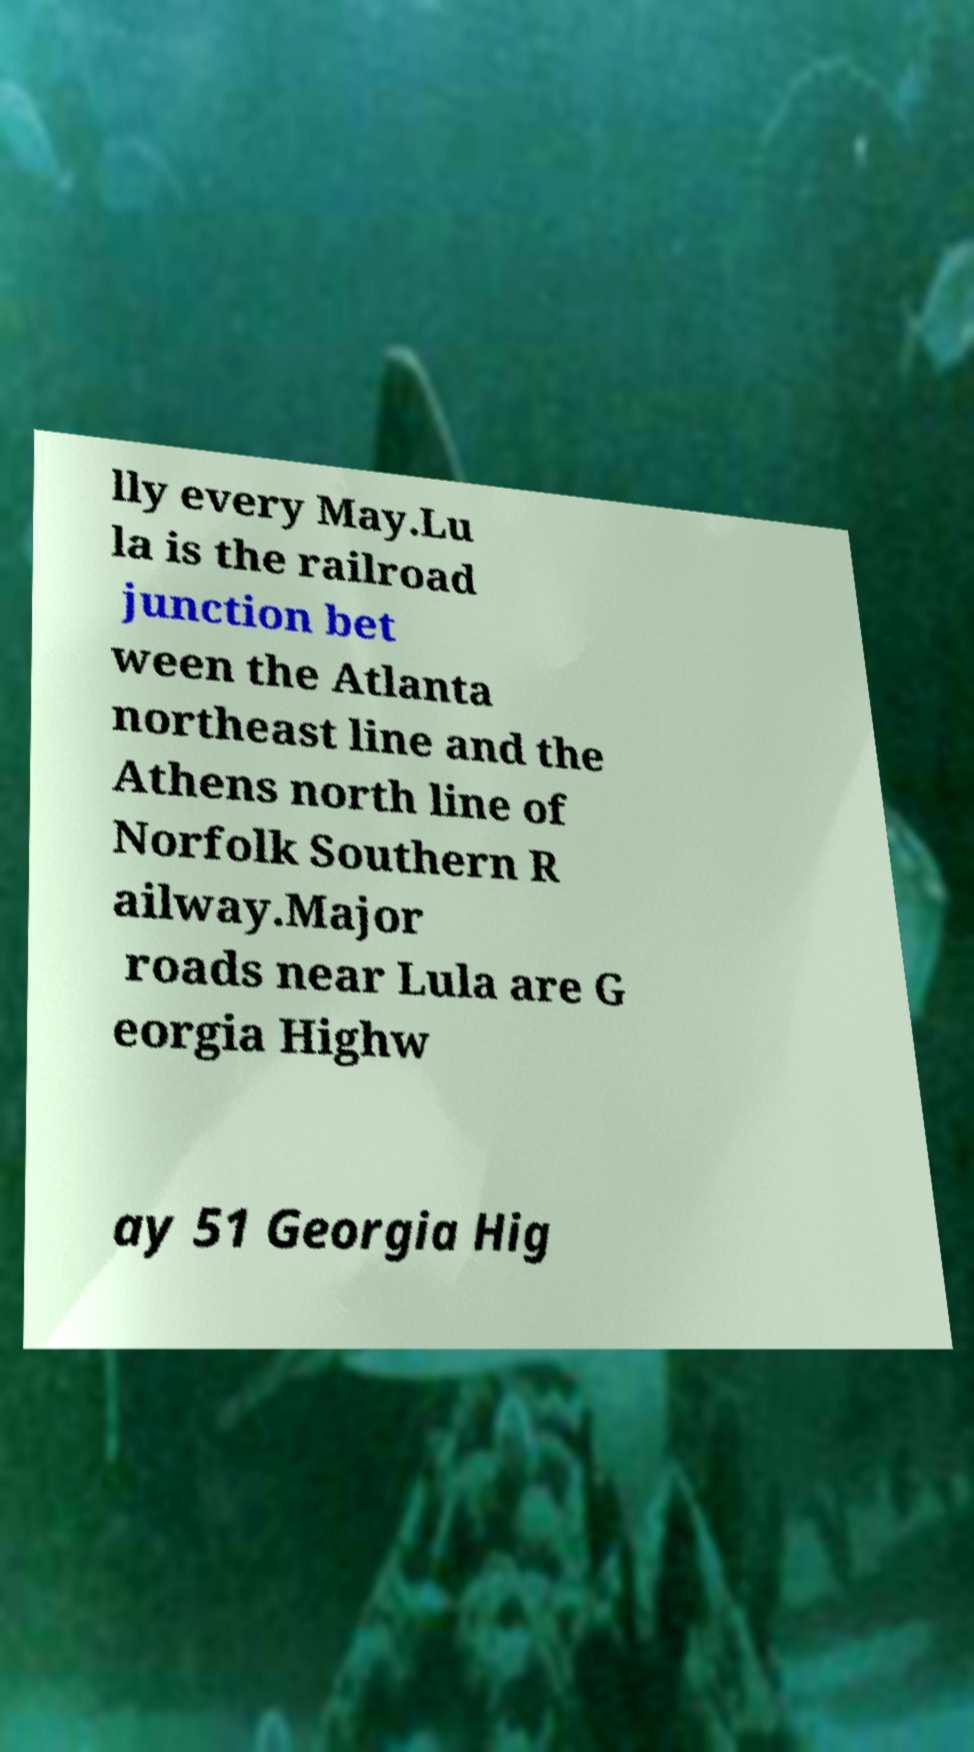Could you extract and type out the text from this image? lly every May.Lu la is the railroad junction bet ween the Atlanta northeast line and the Athens north line of Norfolk Southern R ailway.Major roads near Lula are G eorgia Highw ay 51 Georgia Hig 